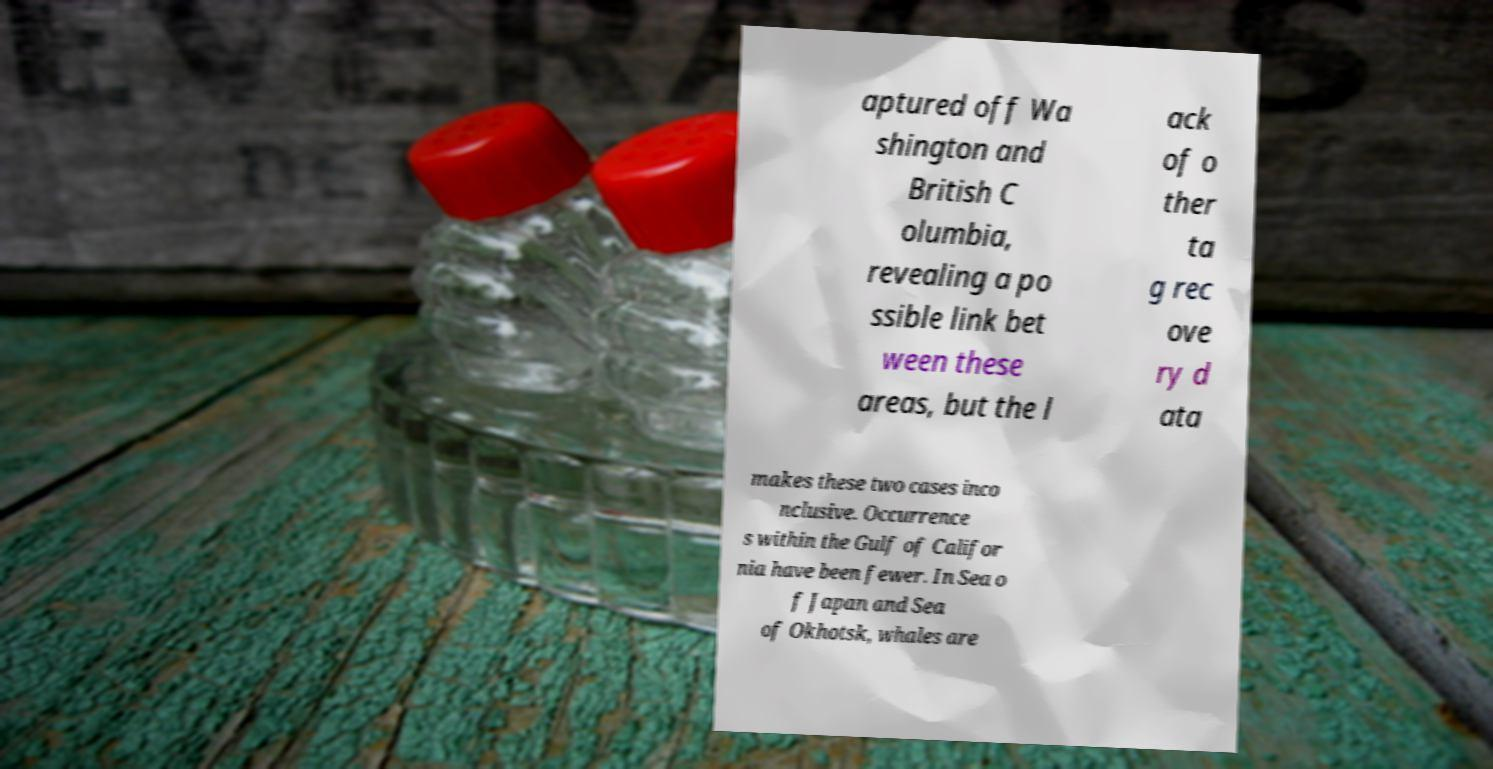I need the written content from this picture converted into text. Can you do that? aptured off Wa shington and British C olumbia, revealing a po ssible link bet ween these areas, but the l ack of o ther ta g rec ove ry d ata makes these two cases inco nclusive. Occurrence s within the Gulf of Califor nia have been fewer. In Sea o f Japan and Sea of Okhotsk, whales are 